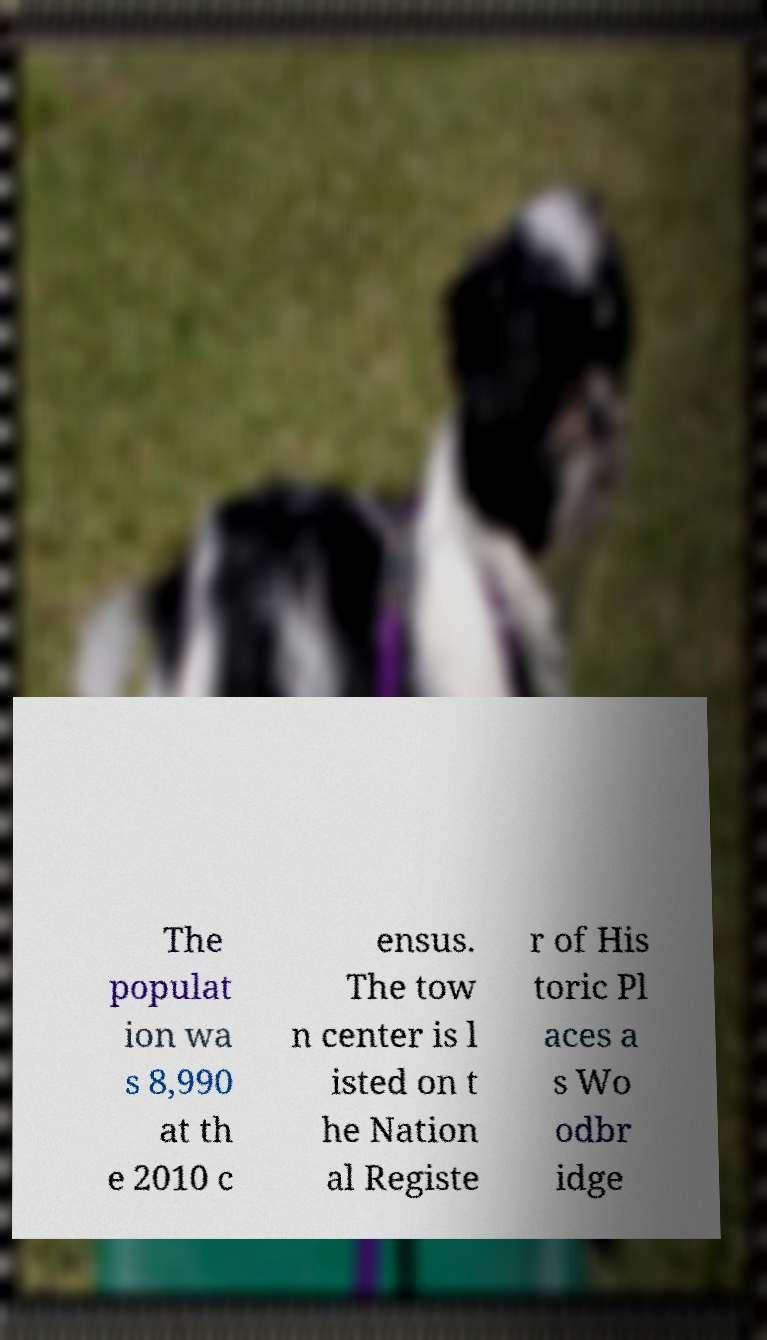Can you accurately transcribe the text from the provided image for me? The populat ion wa s 8,990 at th e 2010 c ensus. The tow n center is l isted on t he Nation al Registe r of His toric Pl aces a s Wo odbr idge 